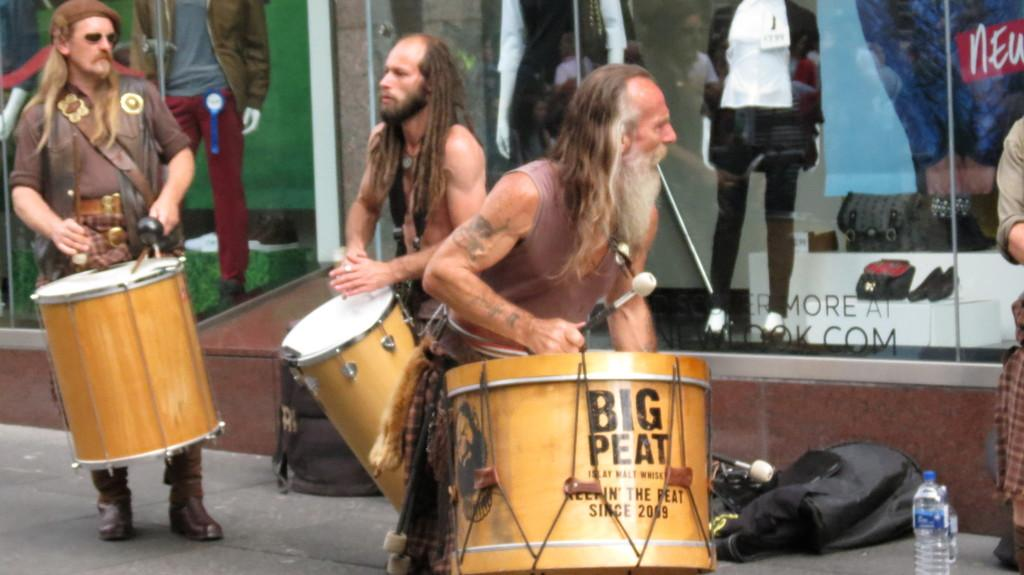How many people are in the image? There are three men in the image. What are the men doing in the image? The men are playing drums. Can you describe the position of the men in the image? The men are standing. What type of shoe can be seen on the drummer's foot in the image? There is no shoe visible on the drummer's foot in the image, as the focus is on the men playing drums and their position. 